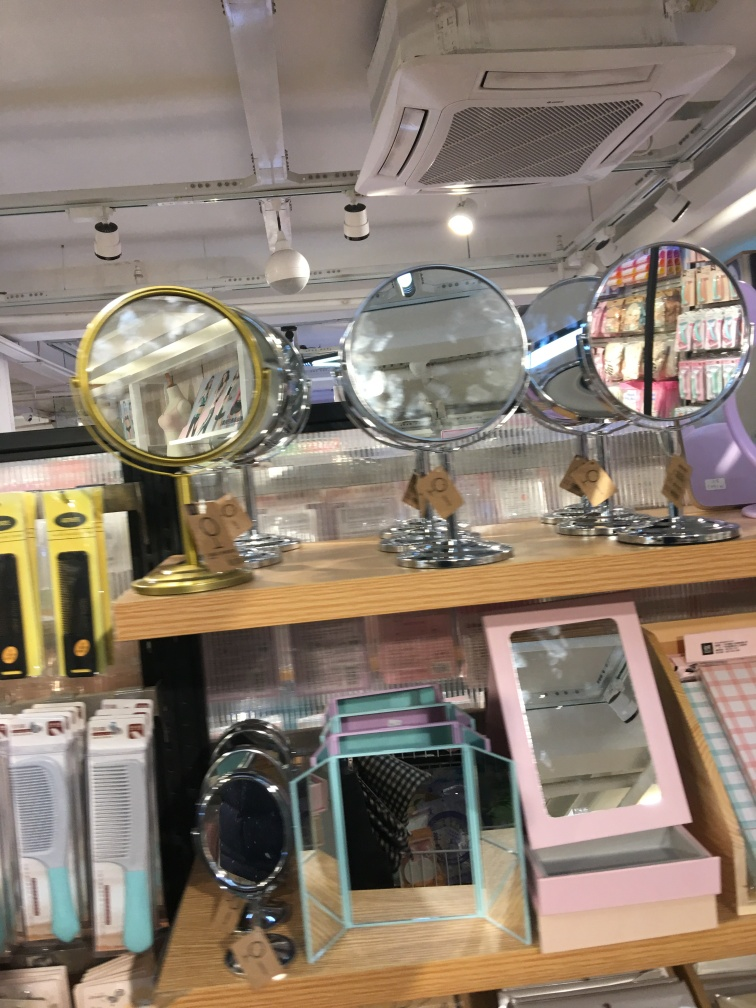Can you tell me what items are being displayed in this image? Certainly! The image shows an assortment of mirrors displayed on a shelf. These include handheld mirrors, compact mirrors, and larger desk mirrors, some with decorative frames. Behind the mirrors, there are some additional items that are a bit harder to identify due to the focus issues, but they appear to be beauty or personal care products. 